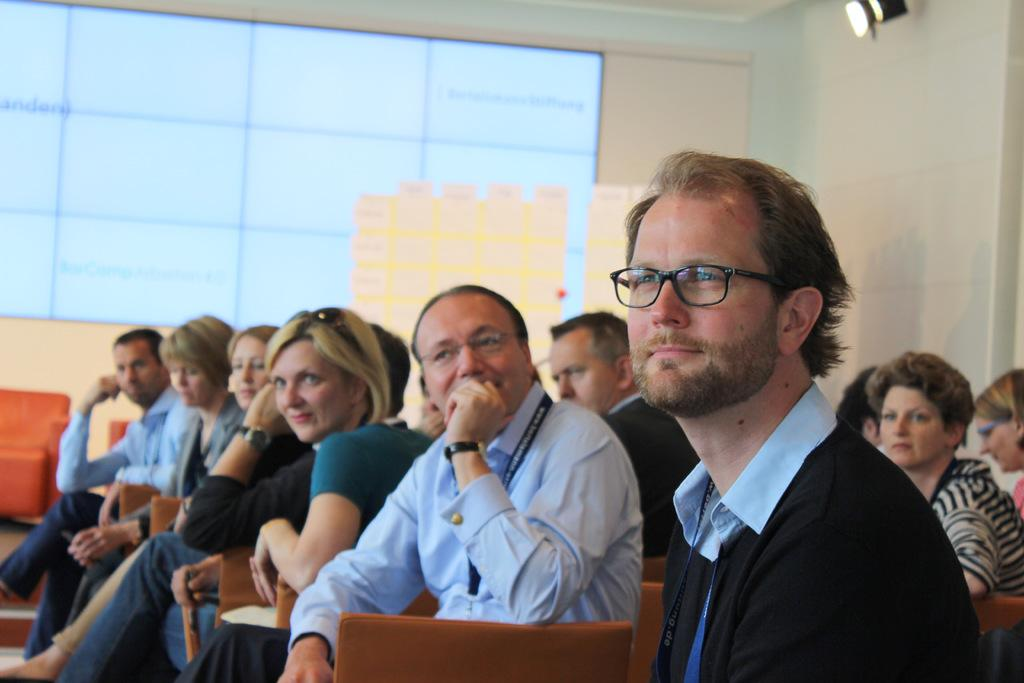What are the people in the image doing? The people in the image are sitting on chairs. Can you describe the gender of the people in the image? There are men and women in the image. What can be seen in the background of the image? There is a wall in the background of the image. What type of education is being taught in the jail in the image? There is no jail or education present in the image; it only shows people sitting on chairs with a wall in the background. 